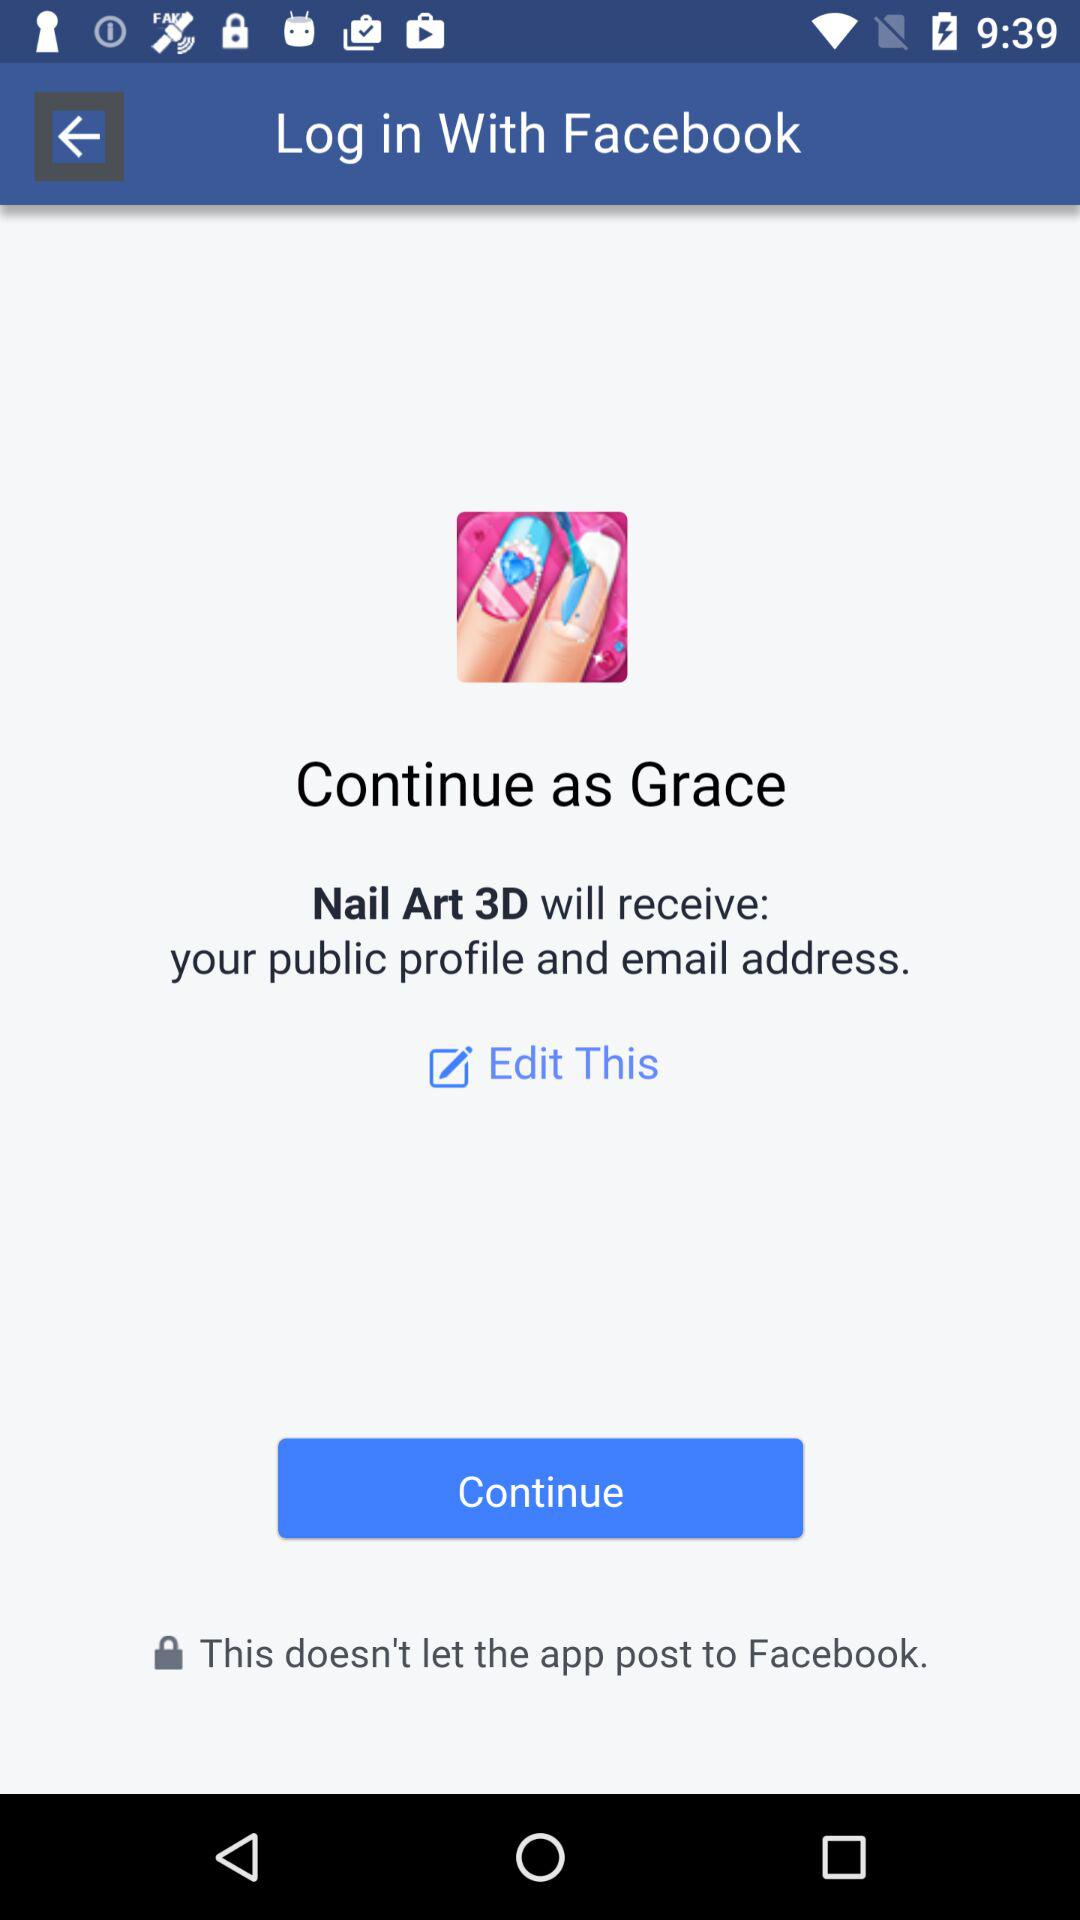What is the name of the user? The name of the user is Grace. 